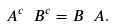<formula> <loc_0><loc_0><loc_500><loc_500>A ^ { c } \ B ^ { c } = B \ A .</formula> 